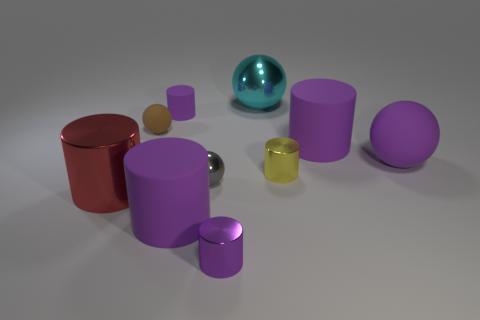Subtract all purple cylinders. How many were subtracted if there are2purple cylinders left? 2 Subtract all small brown balls. How many balls are left? 3 Subtract all blue blocks. How many purple cylinders are left? 4 Subtract all red cylinders. How many cylinders are left? 5 Subtract all cylinders. How many objects are left? 4 Subtract 2 spheres. How many spheres are left? 2 Subtract all blue cylinders. Subtract all blue cubes. How many cylinders are left? 6 Subtract all gray objects. Subtract all big green matte balls. How many objects are left? 9 Add 7 tiny brown matte spheres. How many tiny brown matte spheres are left? 8 Add 5 tiny brown rubber things. How many tiny brown rubber things exist? 6 